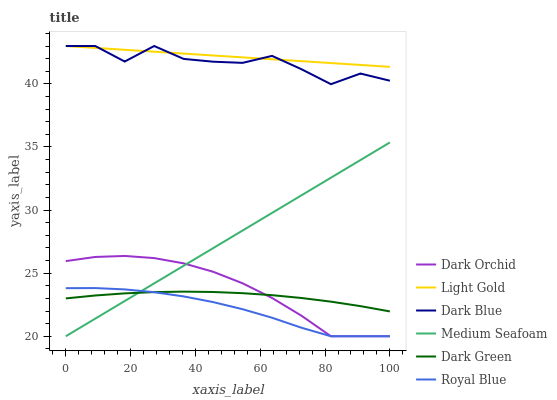Does Royal Blue have the minimum area under the curve?
Answer yes or no. Yes. Does Light Gold have the maximum area under the curve?
Answer yes or no. Yes. Does Dark Orchid have the minimum area under the curve?
Answer yes or no. No. Does Dark Orchid have the maximum area under the curve?
Answer yes or no. No. Is Light Gold the smoothest?
Answer yes or no. Yes. Is Dark Blue the roughest?
Answer yes or no. Yes. Is Dark Orchid the smoothest?
Answer yes or no. No. Is Dark Orchid the roughest?
Answer yes or no. No. Does Dark Orchid have the lowest value?
Answer yes or no. Yes. Does Light Gold have the lowest value?
Answer yes or no. No. Does Light Gold have the highest value?
Answer yes or no. Yes. Does Dark Orchid have the highest value?
Answer yes or no. No. Is Dark Orchid less than Dark Blue?
Answer yes or no. Yes. Is Dark Blue greater than Medium Seafoam?
Answer yes or no. Yes. Does Dark Green intersect Dark Orchid?
Answer yes or no. Yes. Is Dark Green less than Dark Orchid?
Answer yes or no. No. Is Dark Green greater than Dark Orchid?
Answer yes or no. No. Does Dark Orchid intersect Dark Blue?
Answer yes or no. No. 